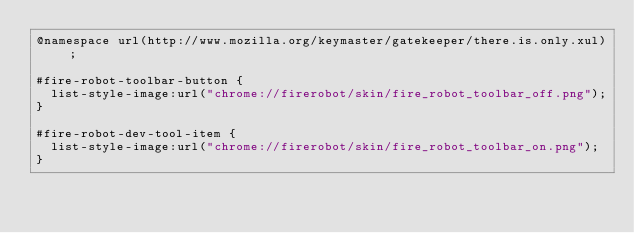Convert code to text. <code><loc_0><loc_0><loc_500><loc_500><_CSS_>@namespace url(http://www.mozilla.org/keymaster/gatekeeper/there.is.only.xul);

#fire-robot-toolbar-button {
  list-style-image:url("chrome://firerobot/skin/fire_robot_toolbar_off.png");
}

#fire-robot-dev-tool-item {
  list-style-image:url("chrome://firerobot/skin/fire_robot_toolbar_on.png");
}</code> 